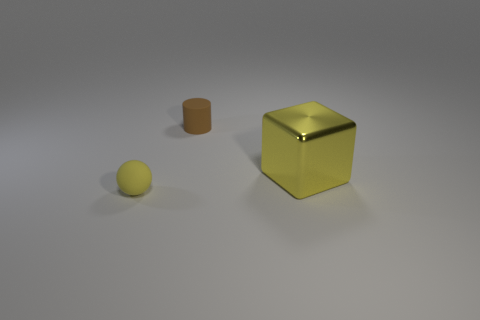Are there any other things that have the same material as the big yellow cube?
Provide a succinct answer. No. There is a yellow thing that is on the right side of the rubber object on the right side of the tiny yellow rubber ball; what is it made of?
Give a very brief answer. Metal. There is a yellow thing behind the object that is in front of the yellow thing behind the yellow sphere; how big is it?
Ensure brevity in your answer.  Large. What number of brown things are either small cylinders or small blocks?
Ensure brevity in your answer.  1. Are there more yellow metal cubes behind the yellow rubber ball than big brown cylinders?
Offer a very short reply. Yes. What number of matte balls have the same size as the rubber cylinder?
Provide a short and direct response. 1. There is a thing that is the same color as the large shiny block; what size is it?
Provide a succinct answer. Small. What number of things are large metallic objects or things in front of the tiny brown matte cylinder?
Make the answer very short. 2. The thing that is both behind the yellow matte sphere and on the left side of the large yellow thing is what color?
Your answer should be compact. Brown. Does the matte cylinder have the same size as the rubber sphere?
Ensure brevity in your answer.  Yes. 